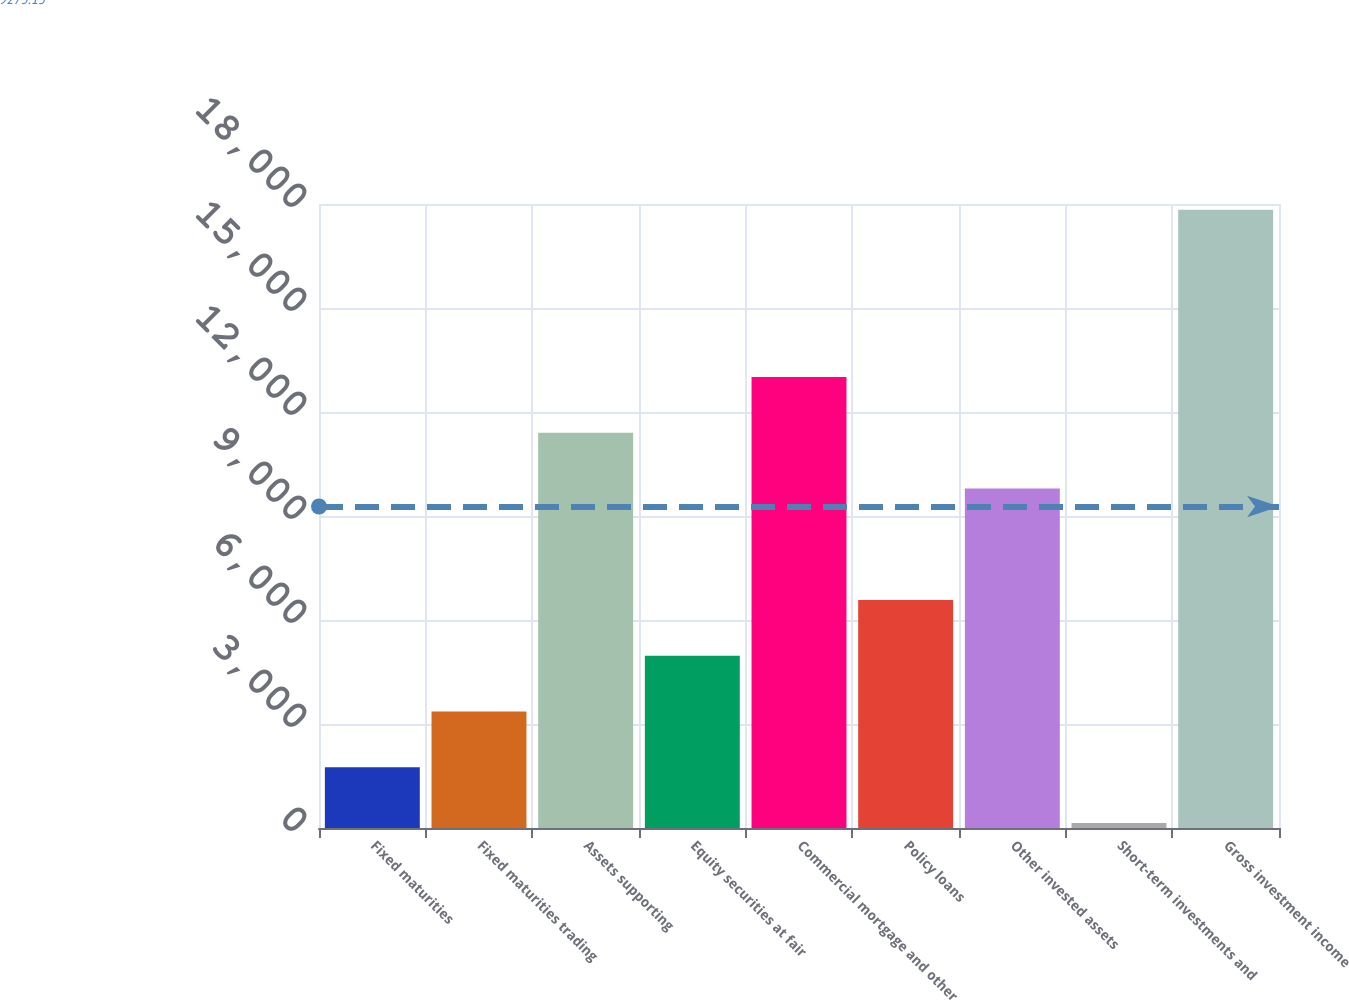<chart> <loc_0><loc_0><loc_500><loc_500><bar_chart><fcel>Fixed maturities<fcel>Fixed maturities trading<fcel>Assets supporting<fcel>Equity securities at fair<fcel>Commercial mortgage and other<fcel>Policy loans<fcel>Other invested assets<fcel>Short-term investments and<fcel>Gross investment income<nl><fcel>1753.1<fcel>3361.2<fcel>11401.7<fcel>4969.3<fcel>13009.8<fcel>6577.4<fcel>9793.6<fcel>145<fcel>17834.1<nl></chart> 